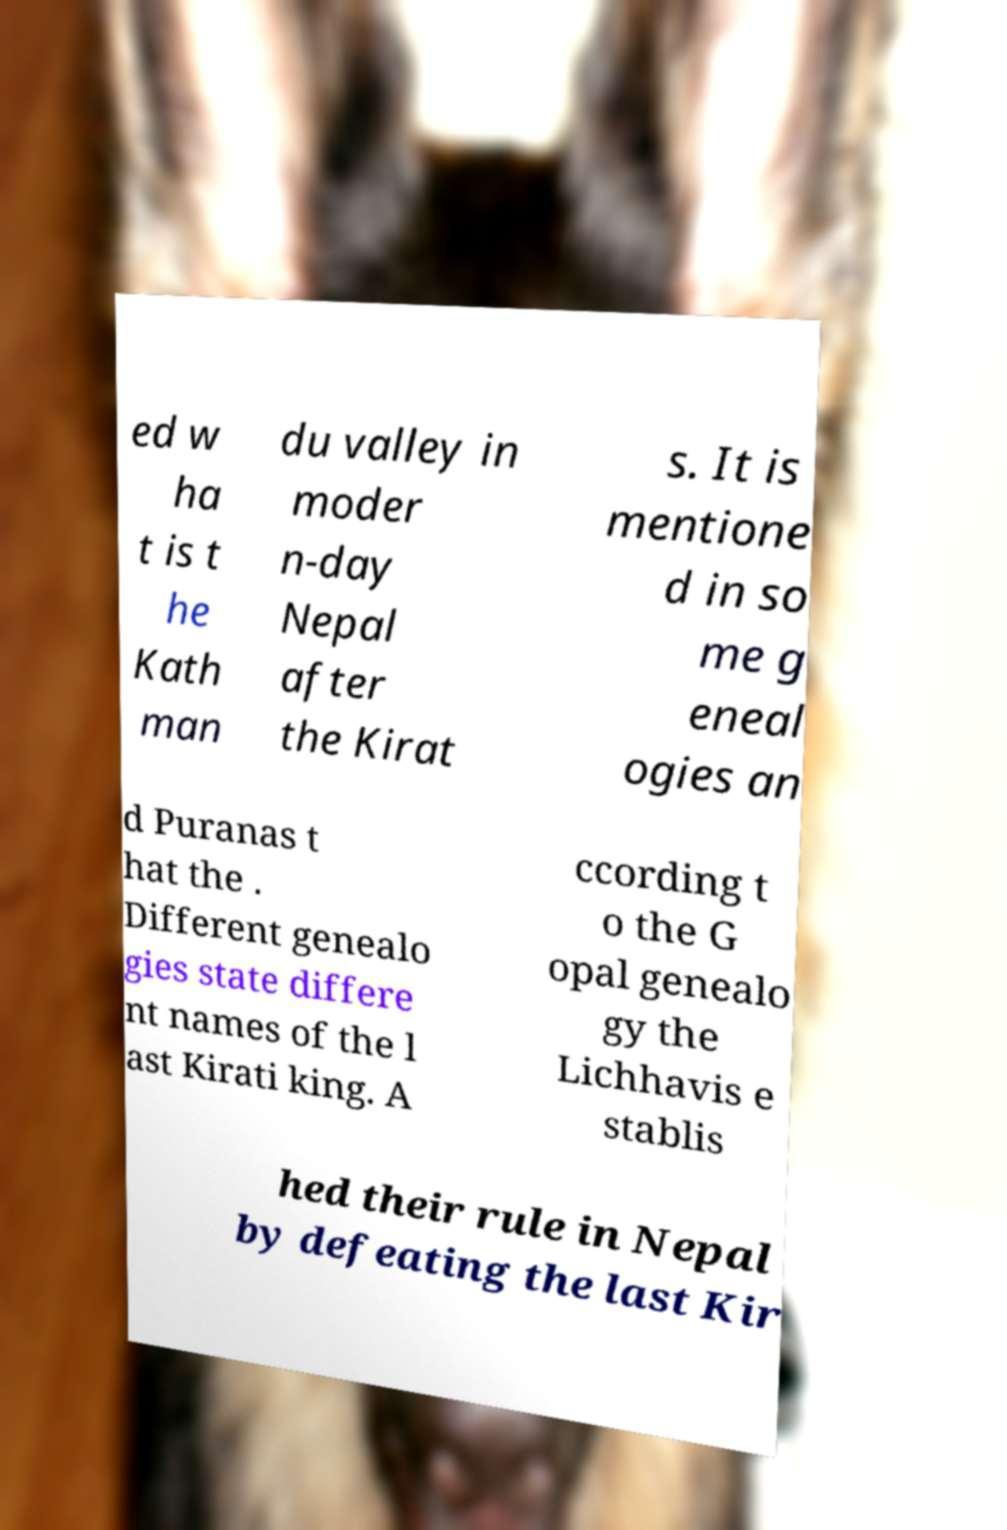What messages or text are displayed in this image? I need them in a readable, typed format. ed w ha t is t he Kath man du valley in moder n-day Nepal after the Kirat s. It is mentione d in so me g eneal ogies an d Puranas t hat the . Different genealo gies state differe nt names of the l ast Kirati king. A ccording t o the G opal genealo gy the Lichhavis e stablis hed their rule in Nepal by defeating the last Kir 